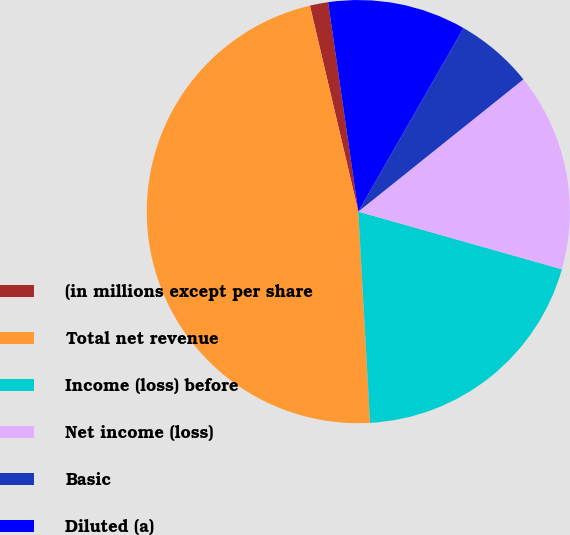<chart> <loc_0><loc_0><loc_500><loc_500><pie_chart><fcel>(in millions except per share<fcel>Total net revenue<fcel>Income (loss) before<fcel>Net income (loss)<fcel>Basic<fcel>Diluted (a)<nl><fcel>1.39%<fcel>47.21%<fcel>19.72%<fcel>15.14%<fcel>5.97%<fcel>10.56%<nl></chart> 